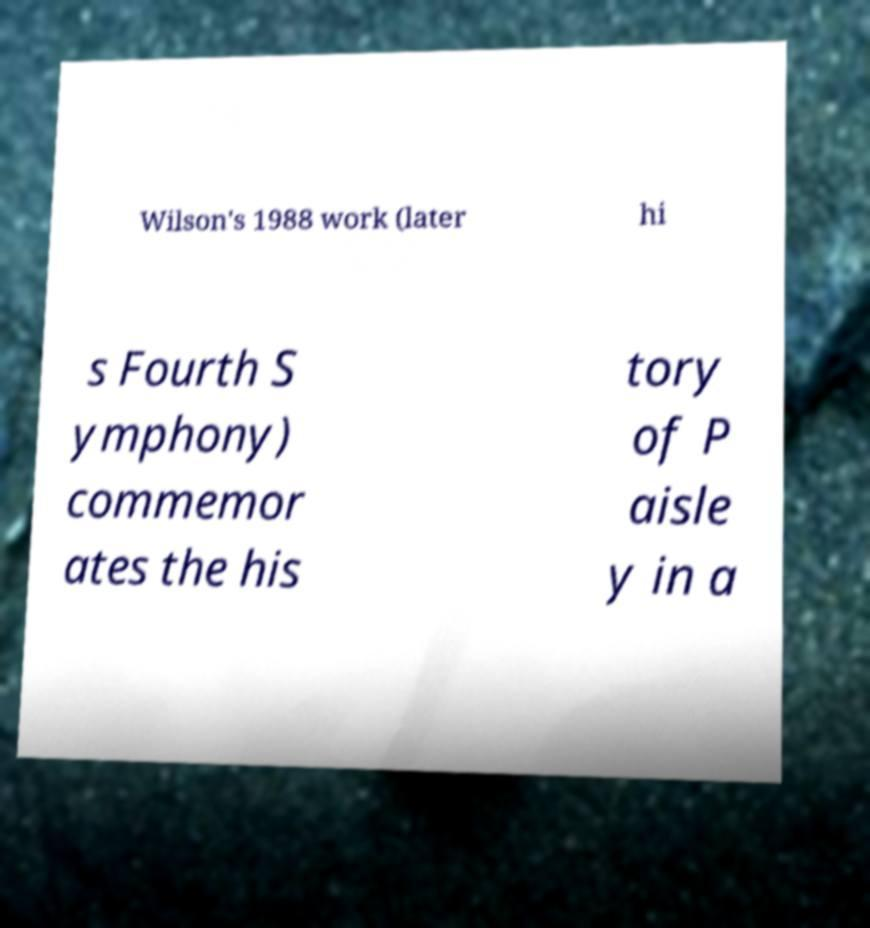What messages or text are displayed in this image? I need them in a readable, typed format. Wilson's 1988 work (later hi s Fourth S ymphony) commemor ates the his tory of P aisle y in a 